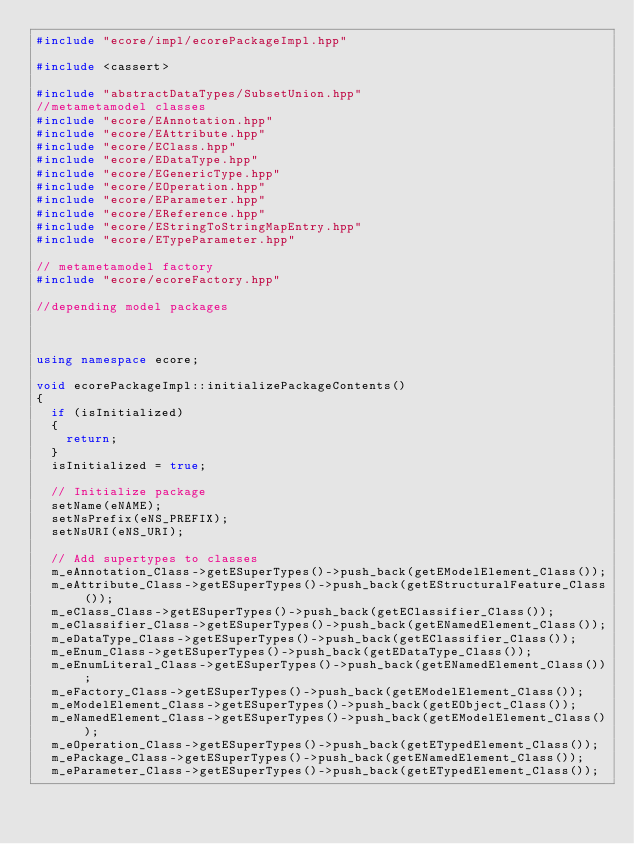<code> <loc_0><loc_0><loc_500><loc_500><_C++_>#include "ecore/impl/ecorePackageImpl.hpp"

#include <cassert>

#include "abstractDataTypes/SubsetUnion.hpp"
//metametamodel classes
#include "ecore/EAnnotation.hpp"
#include "ecore/EAttribute.hpp"
#include "ecore/EClass.hpp"
#include "ecore/EDataType.hpp"
#include "ecore/EGenericType.hpp"
#include "ecore/EOperation.hpp"
#include "ecore/EParameter.hpp"
#include "ecore/EReference.hpp"
#include "ecore/EStringToStringMapEntry.hpp"
#include "ecore/ETypeParameter.hpp"

// metametamodel factory
#include "ecore/ecoreFactory.hpp"

//depending model packages



using namespace ecore;

void ecorePackageImpl::initializePackageContents()
{
	if (isInitialized)
	{
		return;
	}
	isInitialized = true;

	// Initialize package
	setName(eNAME);
	setNsPrefix(eNS_PREFIX);
	setNsURI(eNS_URI);
	
	// Add supertypes to classes
	m_eAnnotation_Class->getESuperTypes()->push_back(getEModelElement_Class());
	m_eAttribute_Class->getESuperTypes()->push_back(getEStructuralFeature_Class());
	m_eClass_Class->getESuperTypes()->push_back(getEClassifier_Class());
	m_eClassifier_Class->getESuperTypes()->push_back(getENamedElement_Class());
	m_eDataType_Class->getESuperTypes()->push_back(getEClassifier_Class());
	m_eEnum_Class->getESuperTypes()->push_back(getEDataType_Class());
	m_eEnumLiteral_Class->getESuperTypes()->push_back(getENamedElement_Class());
	m_eFactory_Class->getESuperTypes()->push_back(getEModelElement_Class());
	m_eModelElement_Class->getESuperTypes()->push_back(getEObject_Class());
	m_eNamedElement_Class->getESuperTypes()->push_back(getEModelElement_Class());
	m_eOperation_Class->getESuperTypes()->push_back(getETypedElement_Class());
	m_ePackage_Class->getESuperTypes()->push_back(getENamedElement_Class());
	m_eParameter_Class->getESuperTypes()->push_back(getETypedElement_Class());</code> 